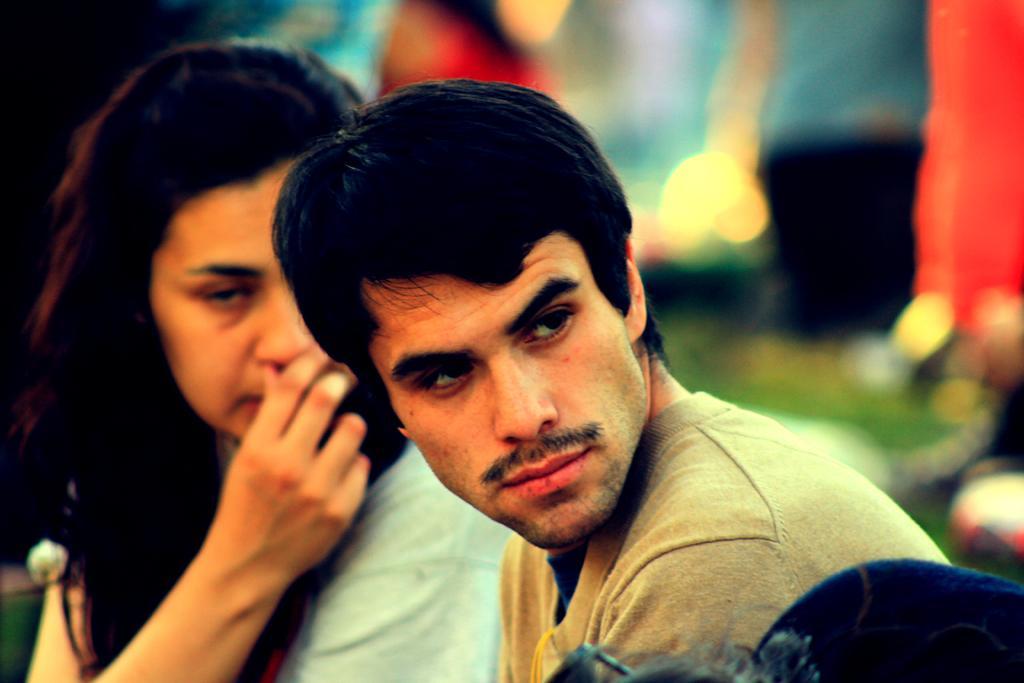Describe this image in one or two sentences. In this image we can see a man and woman. Background it is blur. 